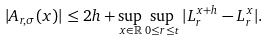Convert formula to latex. <formula><loc_0><loc_0><loc_500><loc_500>| A _ { r , \sigma } ( x ) | \leq 2 h + \sup _ { x \in \mathbb { R } } \sup _ { 0 \leq r \leq t } | L _ { r } ^ { x + h } - L _ { r } ^ { x } | .</formula> 